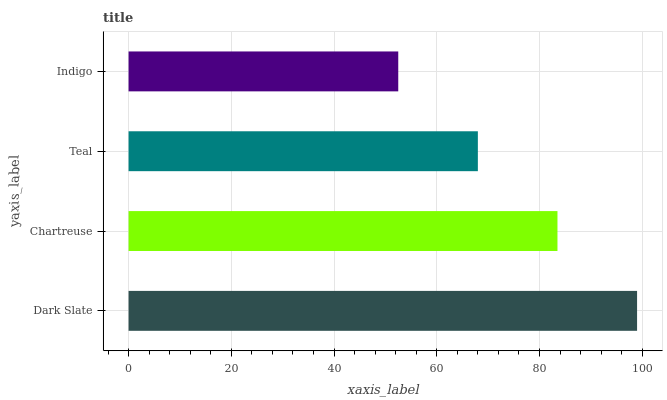Is Indigo the minimum?
Answer yes or no. Yes. Is Dark Slate the maximum?
Answer yes or no. Yes. Is Chartreuse the minimum?
Answer yes or no. No. Is Chartreuse the maximum?
Answer yes or no. No. Is Dark Slate greater than Chartreuse?
Answer yes or no. Yes. Is Chartreuse less than Dark Slate?
Answer yes or no. Yes. Is Chartreuse greater than Dark Slate?
Answer yes or no. No. Is Dark Slate less than Chartreuse?
Answer yes or no. No. Is Chartreuse the high median?
Answer yes or no. Yes. Is Teal the low median?
Answer yes or no. Yes. Is Teal the high median?
Answer yes or no. No. Is Indigo the low median?
Answer yes or no. No. 